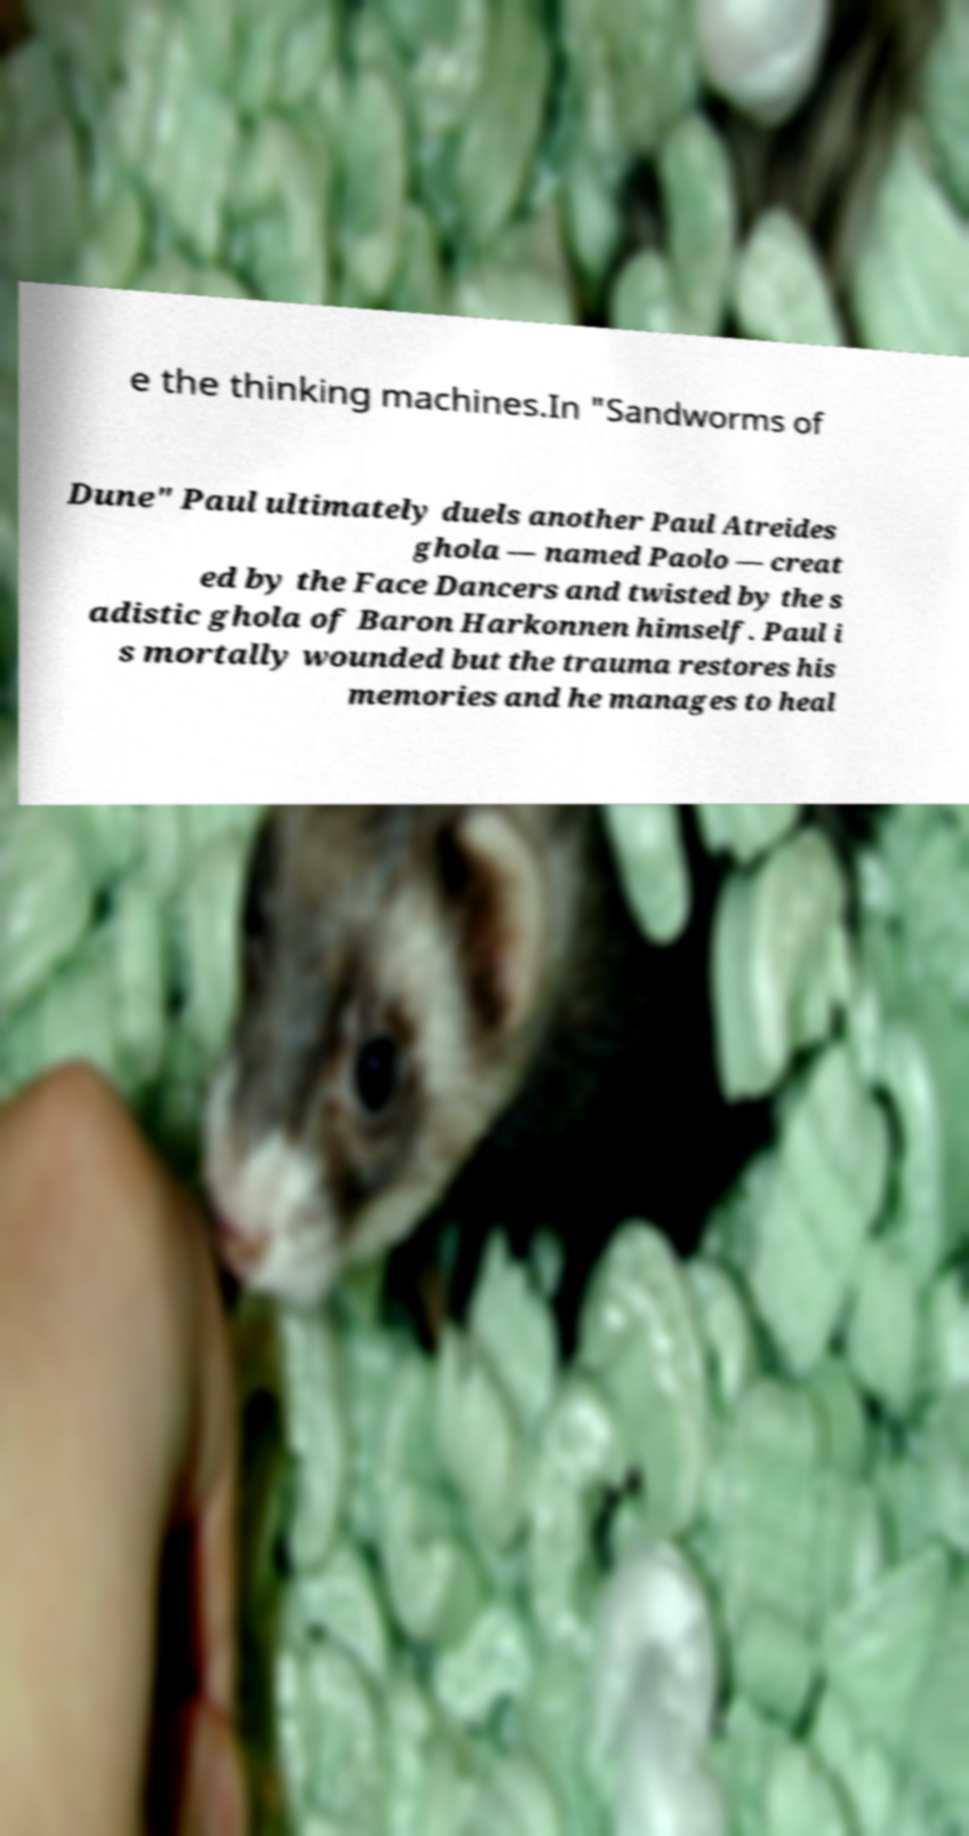Can you accurately transcribe the text from the provided image for me? e the thinking machines.In "Sandworms of Dune" Paul ultimately duels another Paul Atreides ghola — named Paolo — creat ed by the Face Dancers and twisted by the s adistic ghola of Baron Harkonnen himself. Paul i s mortally wounded but the trauma restores his memories and he manages to heal 